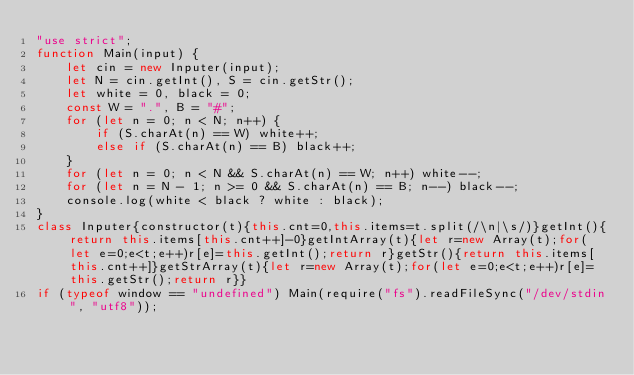<code> <loc_0><loc_0><loc_500><loc_500><_JavaScript_>"use strict";
function Main(input) {
    let cin = new Inputer(input);
    let N = cin.getInt(), S = cin.getStr();
    let white = 0, black = 0;
    const W = ".", B = "#";
    for (let n = 0; n < N; n++) {
        if (S.charAt(n) == W) white++; 
        else if (S.charAt(n) == B) black++;
    }
    for (let n = 0; n < N && S.charAt(n) == W; n++) white--;
    for (let n = N - 1; n >= 0 && S.charAt(n) == B; n--) black--;
    console.log(white < black ? white : black);
}
class Inputer{constructor(t){this.cnt=0,this.items=t.split(/\n|\s/)}getInt(){return this.items[this.cnt++]-0}getIntArray(t){let r=new Array(t);for(let e=0;e<t;e++)r[e]=this.getInt();return r}getStr(){return this.items[this.cnt++]}getStrArray(t){let r=new Array(t);for(let e=0;e<t;e++)r[e]=this.getStr();return r}}
if (typeof window == "undefined") Main(require("fs").readFileSync("/dev/stdin", "utf8"));</code> 